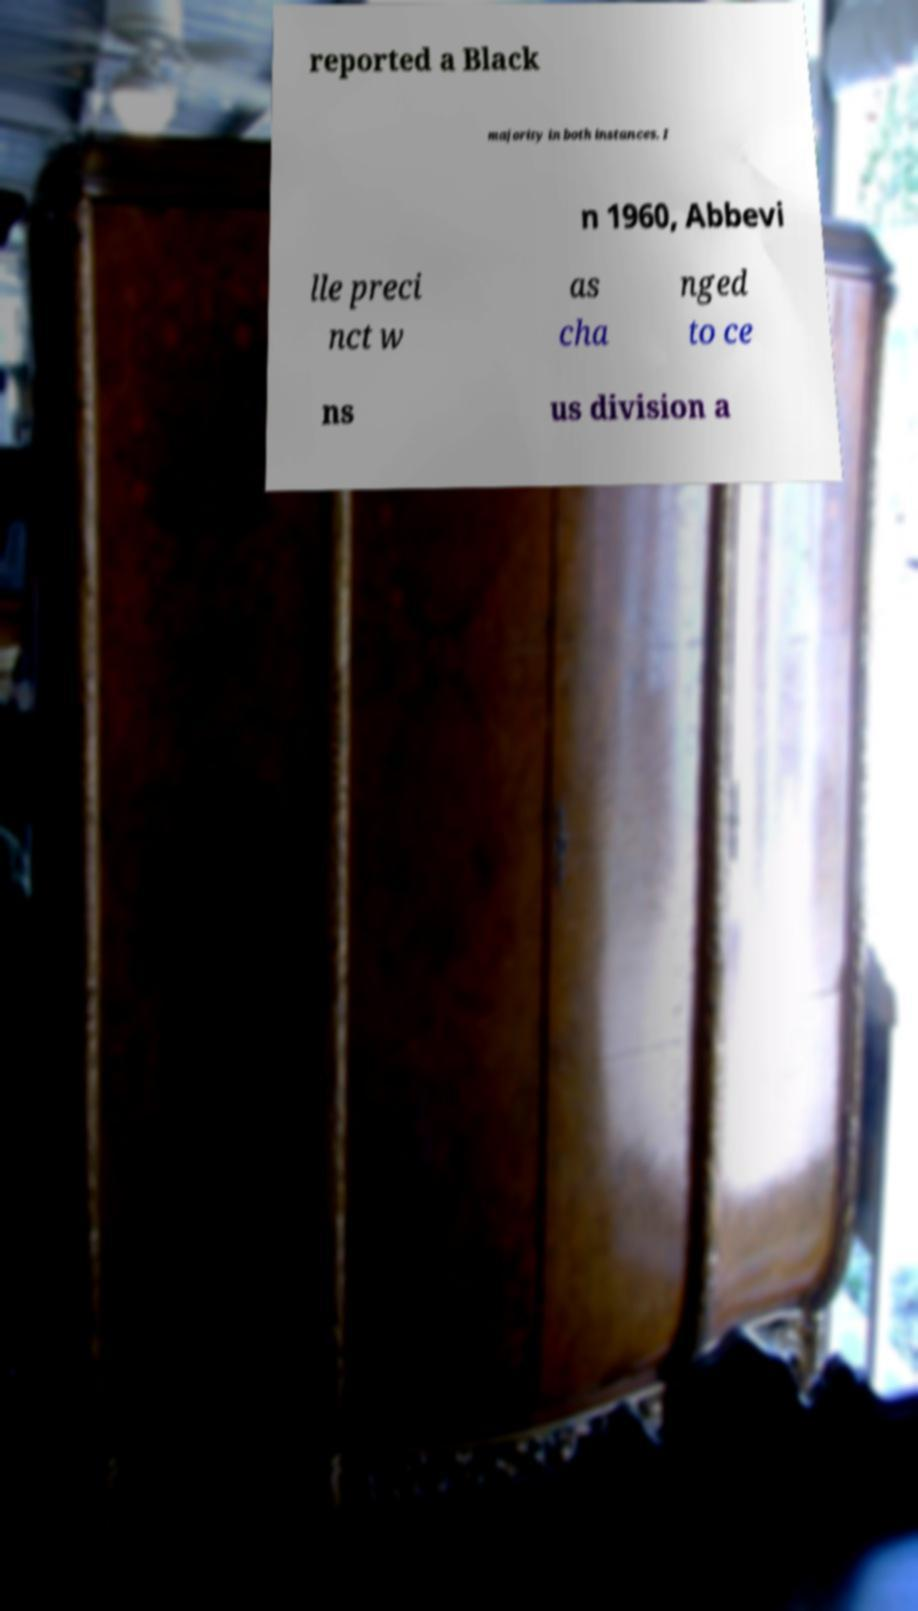For documentation purposes, I need the text within this image transcribed. Could you provide that? reported a Black majority in both instances. I n 1960, Abbevi lle preci nct w as cha nged to ce ns us division a 